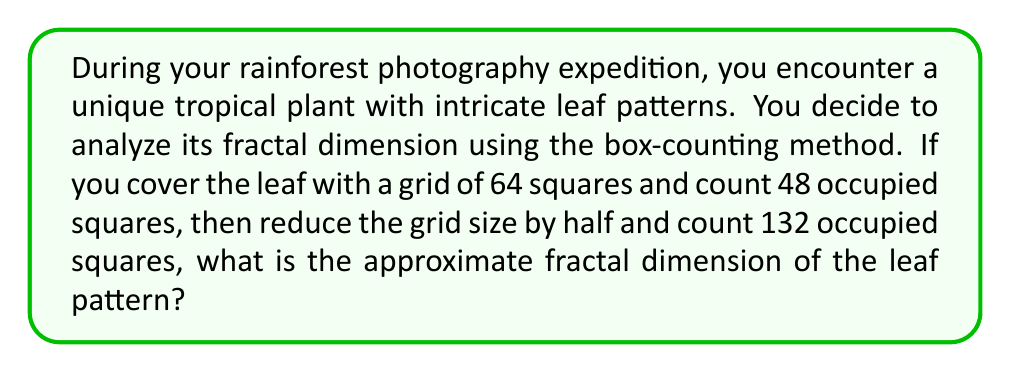Can you solve this math problem? To solve this problem, we'll use the box-counting method to estimate the fractal dimension. The fractal dimension $D$ is given by the formula:

$$D = \frac{\log(N_2) - \log(N_1)}{\log(r_1) - \log(r_2)}$$

Where:
$N_1$ is the number of occupied boxes in the first count
$N_2$ is the number of occupied boxes in the second count
$r_1$ is the size of the boxes in the first count
$r_2$ is the size of the boxes in the second count

Step 1: Identify the given values
$N_1 = 48$ (first count)
$N_2 = 132$ (second count)
$r_1 = 1$ (initial grid size)
$r_2 = \frac{1}{2}$ (grid size reduced by half)

Step 2: Substitute the values into the formula
$$D = \frac{\log(132) - \log(48)}{\log(1) - \log(\frac{1}{2})}$$

Step 3: Simplify the numerator
$$D = \frac{\log(132) - \log(48)}{\log(2)}$$

Step 4: Calculate the logarithms
$$D = \frac{4.8828 - 3.8712}{0.6931}$$

Step 5: Perform the final calculation
$$D = \frac{1.0116}{0.6931} \approx 1.4596$$

Therefore, the approximate fractal dimension of the leaf pattern is 1.4596.
Answer: 1.4596 